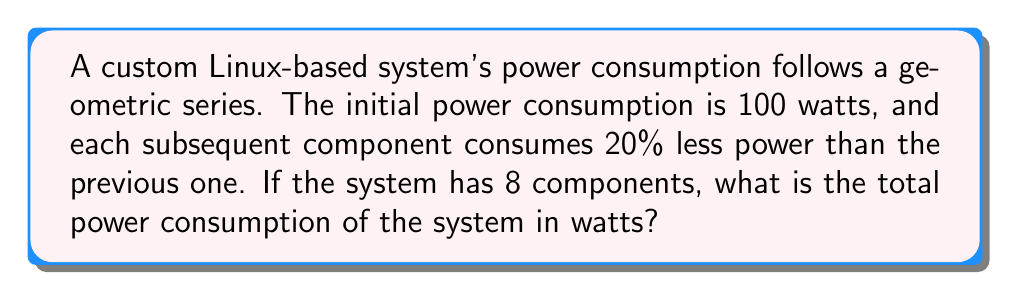Solve this math problem. Let's approach this step-by-step:

1) We have a geometric series with:
   - First term: $a = 100$ watts
   - Common ratio: $r = 1 - 0.20 = 0.80$ (each term is 80% of the previous)
   - Number of terms: $n = 8$ (8 components)

2) The formula for the sum of a geometric series is:
   $$S_n = \frac{a(1-r^n)}{1-r}$$
   where $S_n$ is the sum of $n$ terms.

3) Let's substitute our values:
   $$S_8 = \frac{100(1-0.80^8)}{1-0.80}$$

4) Simplify the numerator:
   $0.80^8 = 0.16777216$
   $1 - 0.80^8 = 1 - 0.16777216 = 0.83222784$

5) Now our equation looks like:
   $$S_8 = \frac{100(0.83222784)}{0.20}$$

6) Simplify:
   $$S_8 = \frac{83.222784}{0.20} = 416.11392$$

7) Rounding to two decimal places:
   $$S_8 \approx 416.11$$ watts
Answer: 416.11 watts 